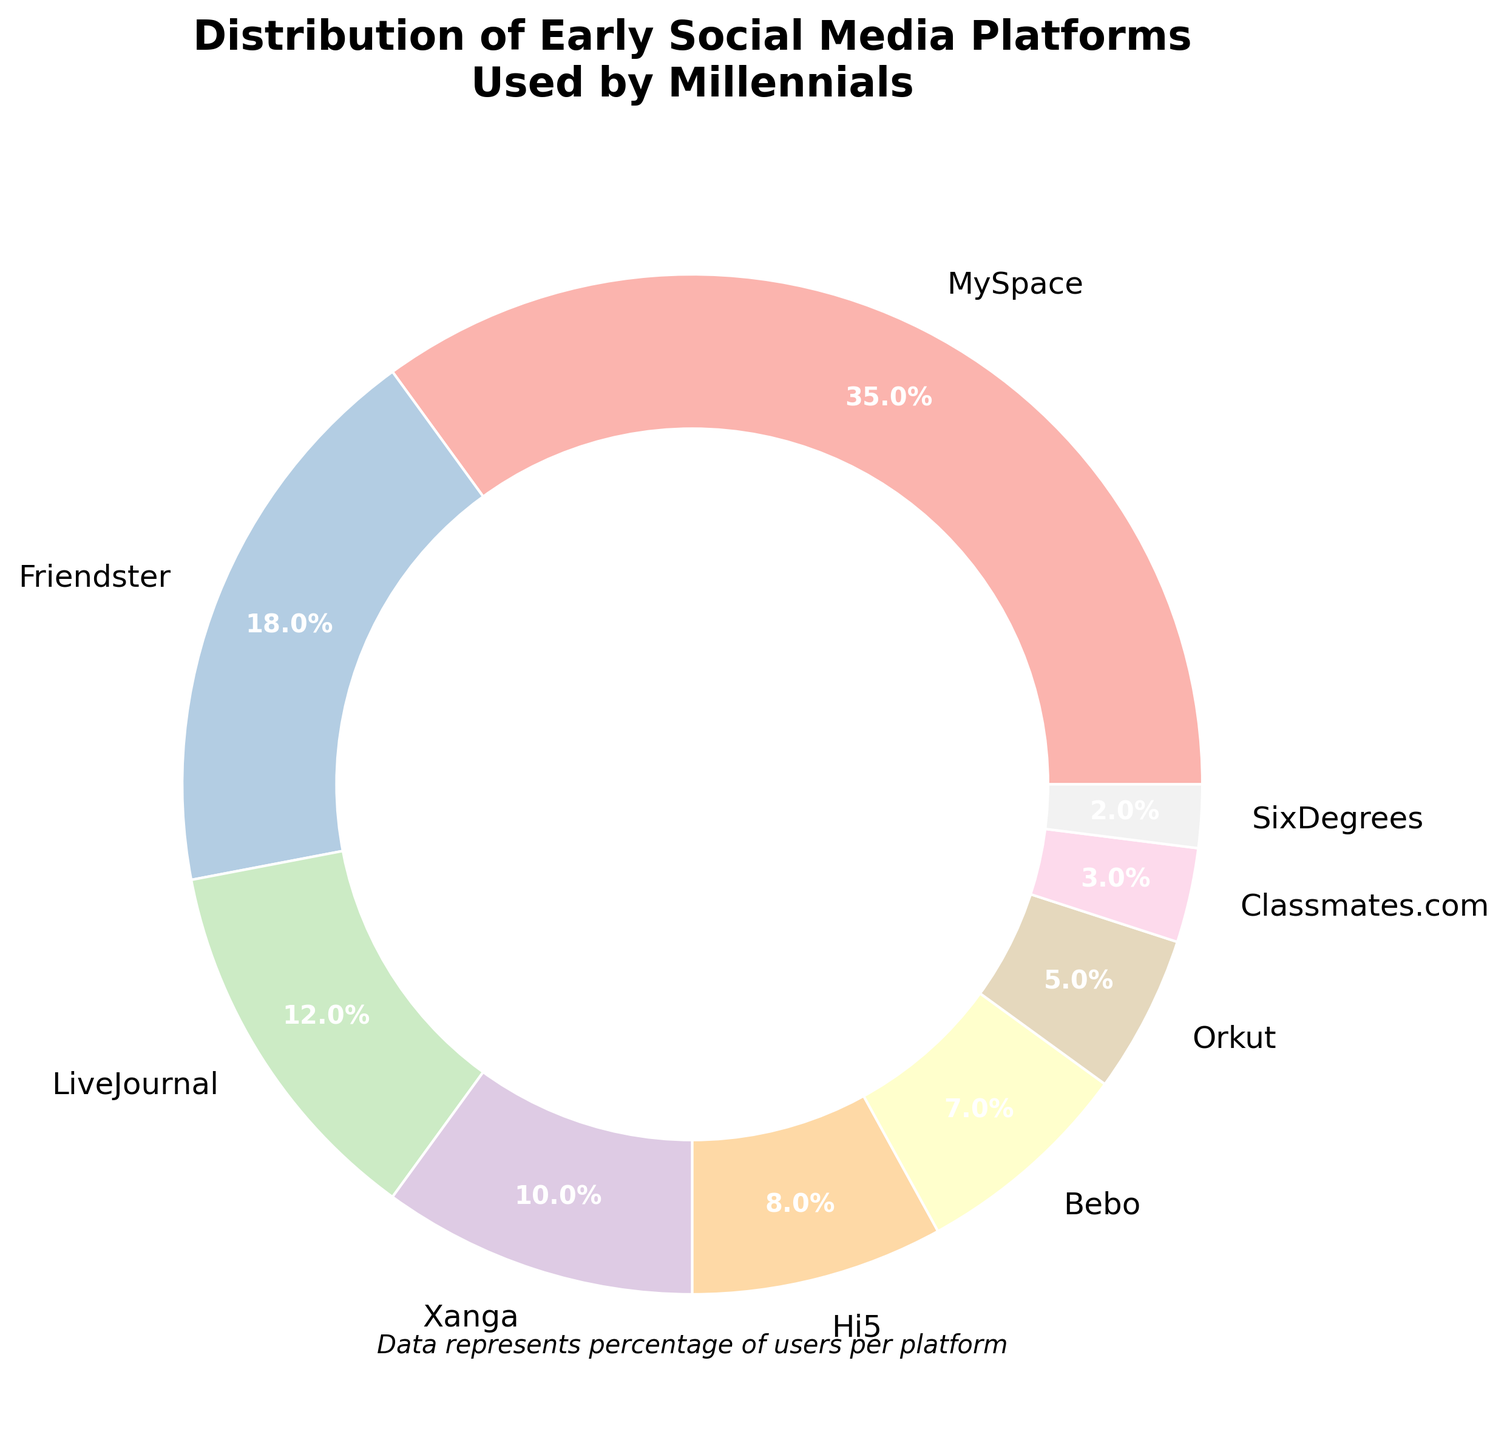Which platform has the highest percentage of users? Identify the slice with the largest percentage label. MySpace shows 35%, which is the highest among all platforms.
Answer: MySpace Which two platforms together make up more than half of the total percentage? Sum the percentages of MySpace and Friendster (35% + 18% = 53%), which is more than 50%.
Answer: MySpace and Friendster Which platform has the smallest percentage of users? Look for the slice with the smallest percentage label. SixDegrees shows 2%, which is the smallest.
Answer: SixDegrees How much more popular is MySpace compared to Xanga? Subtract the percentage of Xanga from MySpace (35% - 10%).
Answer: 25% Are there any platforms with the same percentage of users? Check each percentage label for duplicates. No two platforms share the same percentage in the pie chart.
Answer: No Which platform has a larger share: LiveJournal or Orkut? Compare the percentage of LiveJournal (12%) with that of Orkut (5%). LiveJournal is larger.
Answer: LiveJournal What is the combined percentage of the three least popular platforms? Add the percentages of SixDegrees, Classmates.com, and Orkut (2% + 3% + 5%).
Answer: 10% Approximately what fraction of the chart does LiveJournal occupy? LiveJournal occupies 12%, close to 1/8 of 100%.
Answer: 1/8 Which visual feature helps identify the central circle added to the chart layout? The white circle at the center is the key visual feature that indicates the chart is a donut rather than a pie chart.
Answer: White circle 